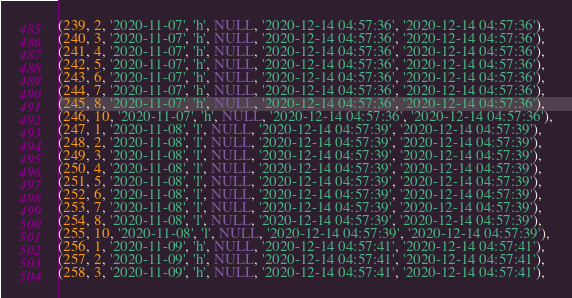Convert code to text. <code><loc_0><loc_0><loc_500><loc_500><_SQL_>(239, 2, '2020-11-07', 'h', NULL, '2020-12-14 04:57:36', '2020-12-14 04:57:36'),
(240, 3, '2020-11-07', 'h', NULL, '2020-12-14 04:57:36', '2020-12-14 04:57:36'),
(241, 4, '2020-11-07', 'h', NULL, '2020-12-14 04:57:36', '2020-12-14 04:57:36'),
(242, 5, '2020-11-07', 'h', NULL, '2020-12-14 04:57:36', '2020-12-14 04:57:36'),
(243, 6, '2020-11-07', 'h', NULL, '2020-12-14 04:57:36', '2020-12-14 04:57:36'),
(244, 7, '2020-11-07', 'h', NULL, '2020-12-14 04:57:36', '2020-12-14 04:57:36'),
(245, 8, '2020-11-07', 'h', NULL, '2020-12-14 04:57:36', '2020-12-14 04:57:36'),
(246, 10, '2020-11-07', 'h', NULL, '2020-12-14 04:57:36', '2020-12-14 04:57:36'),
(247, 1, '2020-11-08', 'l', NULL, '2020-12-14 04:57:39', '2020-12-14 04:57:39'),
(248, 2, '2020-11-08', 'l', NULL, '2020-12-14 04:57:39', '2020-12-14 04:57:39'),
(249, 3, '2020-11-08', 'l', NULL, '2020-12-14 04:57:39', '2020-12-14 04:57:39'),
(250, 4, '2020-11-08', 'l', NULL, '2020-12-14 04:57:39', '2020-12-14 04:57:39'),
(251, 5, '2020-11-08', 'l', NULL, '2020-12-14 04:57:39', '2020-12-14 04:57:39'),
(252, 6, '2020-11-08', 'l', NULL, '2020-12-14 04:57:39', '2020-12-14 04:57:39'),
(253, 7, '2020-11-08', 'l', NULL, '2020-12-14 04:57:39', '2020-12-14 04:57:39'),
(254, 8, '2020-11-08', 'l', NULL, '2020-12-14 04:57:39', '2020-12-14 04:57:39'),
(255, 10, '2020-11-08', 'l', NULL, '2020-12-14 04:57:39', '2020-12-14 04:57:39'),
(256, 1, '2020-11-09', 'h', NULL, '2020-12-14 04:57:41', '2020-12-14 04:57:41'),
(257, 2, '2020-11-09', 'h', NULL, '2020-12-14 04:57:41', '2020-12-14 04:57:41'),
(258, 3, '2020-11-09', 'h', NULL, '2020-12-14 04:57:41', '2020-12-14 04:57:41'),</code> 